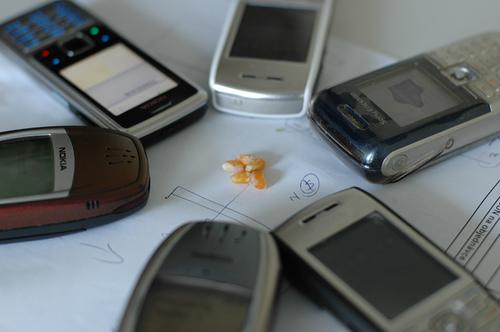What does the item in the middle of the phones look like? kernels 